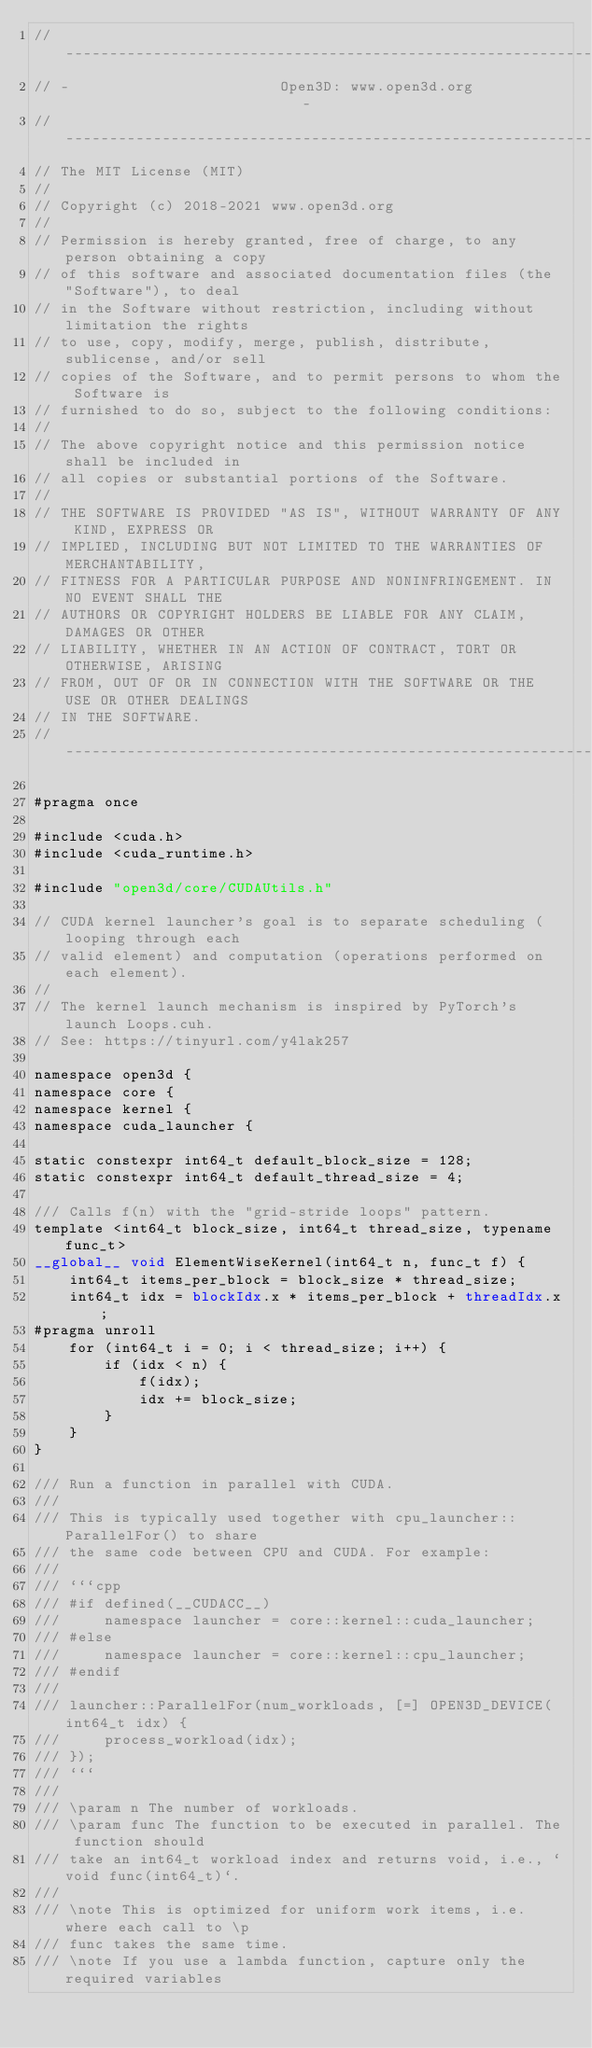<code> <loc_0><loc_0><loc_500><loc_500><_Cuda_>// ----------------------------------------------------------------------------
// -                        Open3D: www.open3d.org                            -
// ----------------------------------------------------------------------------
// The MIT License (MIT)
//
// Copyright (c) 2018-2021 www.open3d.org
//
// Permission is hereby granted, free of charge, to any person obtaining a copy
// of this software and associated documentation files (the "Software"), to deal
// in the Software without restriction, including without limitation the rights
// to use, copy, modify, merge, publish, distribute, sublicense, and/or sell
// copies of the Software, and to permit persons to whom the Software is
// furnished to do so, subject to the following conditions:
//
// The above copyright notice and this permission notice shall be included in
// all copies or substantial portions of the Software.
//
// THE SOFTWARE IS PROVIDED "AS IS", WITHOUT WARRANTY OF ANY KIND, EXPRESS OR
// IMPLIED, INCLUDING BUT NOT LIMITED TO THE WARRANTIES OF MERCHANTABILITY,
// FITNESS FOR A PARTICULAR PURPOSE AND NONINFRINGEMENT. IN NO EVENT SHALL THE
// AUTHORS OR COPYRIGHT HOLDERS BE LIABLE FOR ANY CLAIM, DAMAGES OR OTHER
// LIABILITY, WHETHER IN AN ACTION OF CONTRACT, TORT OR OTHERWISE, ARISING
// FROM, OUT OF OR IN CONNECTION WITH THE SOFTWARE OR THE USE OR OTHER DEALINGS
// IN THE SOFTWARE.
// ----------------------------------------------------------------------------

#pragma once

#include <cuda.h>
#include <cuda_runtime.h>

#include "open3d/core/CUDAUtils.h"

// CUDA kernel launcher's goal is to separate scheduling (looping through each
// valid element) and computation (operations performed on each element).
//
// The kernel launch mechanism is inspired by PyTorch's launch Loops.cuh.
// See: https://tinyurl.com/y4lak257

namespace open3d {
namespace core {
namespace kernel {
namespace cuda_launcher {

static constexpr int64_t default_block_size = 128;
static constexpr int64_t default_thread_size = 4;

/// Calls f(n) with the "grid-stride loops" pattern.
template <int64_t block_size, int64_t thread_size, typename func_t>
__global__ void ElementWiseKernel(int64_t n, func_t f) {
    int64_t items_per_block = block_size * thread_size;
    int64_t idx = blockIdx.x * items_per_block + threadIdx.x;
#pragma unroll
    for (int64_t i = 0; i < thread_size; i++) {
        if (idx < n) {
            f(idx);
            idx += block_size;
        }
    }
}

/// Run a function in parallel with CUDA.
///
/// This is typically used together with cpu_launcher::ParallelFor() to share
/// the same code between CPU and CUDA. For example:
///
/// ```cpp
/// #if defined(__CUDACC__)
///     namespace launcher = core::kernel::cuda_launcher;
/// #else
///     namespace launcher = core::kernel::cpu_launcher;
/// #endif
///
/// launcher::ParallelFor(num_workloads, [=] OPEN3D_DEVICE(int64_t idx) {
///     process_workload(idx);
/// });
/// ```
///
/// \param n The number of workloads.
/// \param func The function to be executed in parallel. The function should
/// take an int64_t workload index and returns void, i.e., `void func(int64_t)`.
///
/// \note This is optimized for uniform work items, i.e. where each call to \p
/// func takes the same time.
/// \note If you use a lambda function, capture only the required variables</code> 